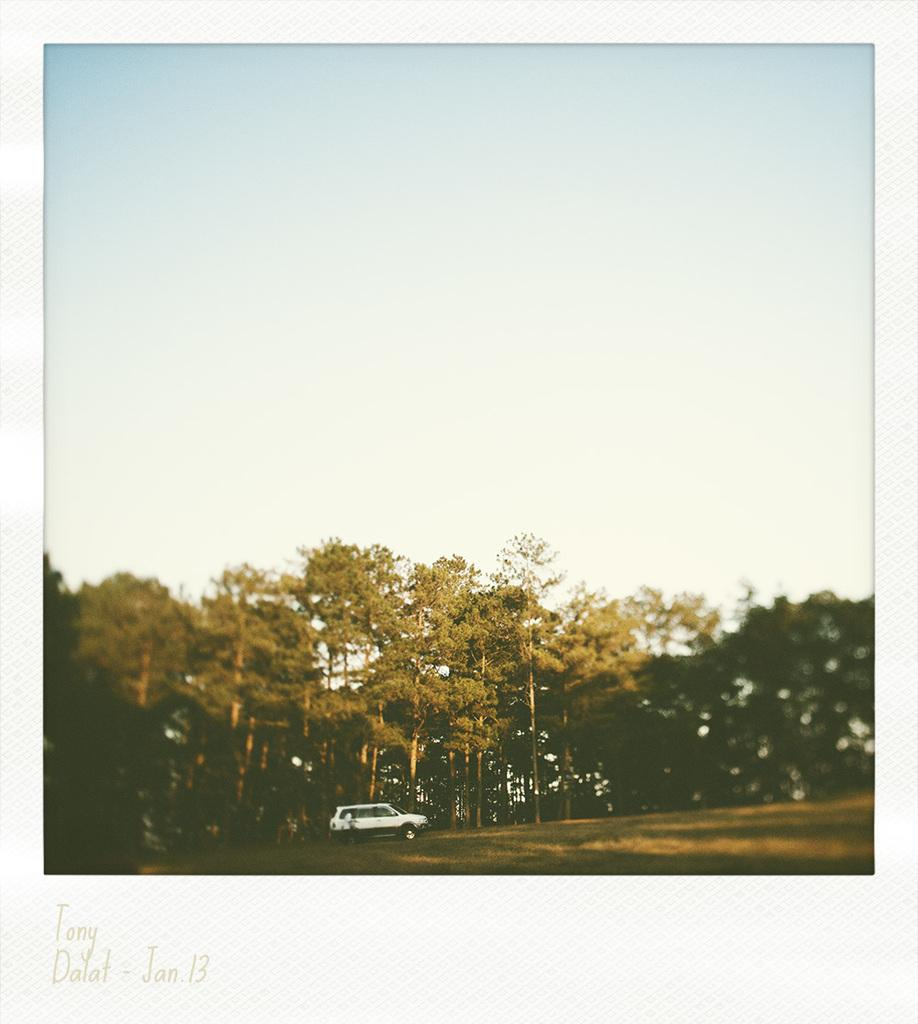What is the main subject of the image? There is a vehicle in the image. What else can be seen in the image besides the vehicle? There are trees and the sky visible in the image. Is there any text or marking on the image? Yes, there is a watermark at the bottom of the image. What time of day is it in the image, and is it during the summer? The time of day and season are not mentioned in the image, so it cannot be determined if it is during the afternoon or summer. 